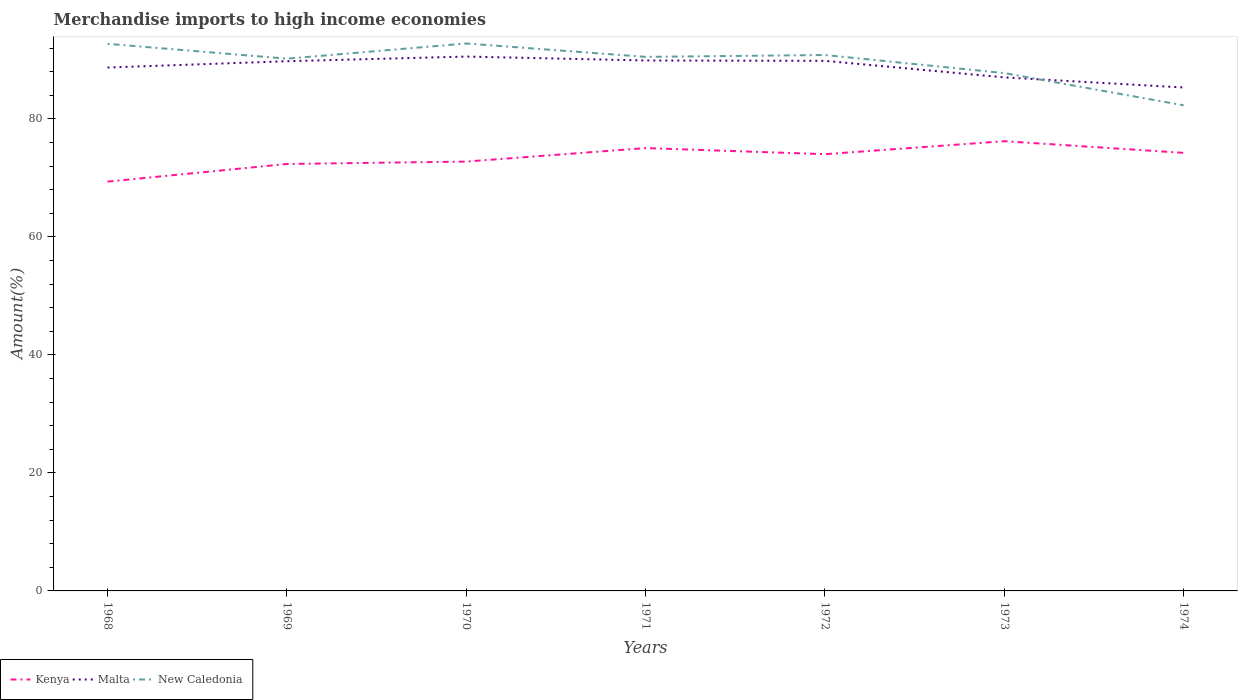Across all years, what is the maximum percentage of amount earned from merchandise imports in New Caledonia?
Offer a terse response. 82.3. In which year was the percentage of amount earned from merchandise imports in Malta maximum?
Ensure brevity in your answer.  1974. What is the total percentage of amount earned from merchandise imports in Kenya in the graph?
Give a very brief answer. -0.4. What is the difference between the highest and the second highest percentage of amount earned from merchandise imports in New Caledonia?
Make the answer very short. 10.48. Does the graph contain any zero values?
Ensure brevity in your answer.  No. Does the graph contain grids?
Provide a short and direct response. No. Where does the legend appear in the graph?
Provide a short and direct response. Bottom left. How many legend labels are there?
Keep it short and to the point. 3. How are the legend labels stacked?
Provide a short and direct response. Horizontal. What is the title of the graph?
Your answer should be compact. Merchandise imports to high income economies. What is the label or title of the X-axis?
Offer a terse response. Years. What is the label or title of the Y-axis?
Your answer should be compact. Amount(%). What is the Amount(%) of Kenya in 1968?
Keep it short and to the point. 69.36. What is the Amount(%) of Malta in 1968?
Your response must be concise. 88.7. What is the Amount(%) of New Caledonia in 1968?
Your response must be concise. 92.72. What is the Amount(%) of Kenya in 1969?
Your answer should be compact. 72.36. What is the Amount(%) in Malta in 1969?
Ensure brevity in your answer.  89.77. What is the Amount(%) of New Caledonia in 1969?
Provide a short and direct response. 90.2. What is the Amount(%) in Kenya in 1970?
Provide a short and direct response. 72.76. What is the Amount(%) of Malta in 1970?
Your response must be concise. 90.56. What is the Amount(%) of New Caledonia in 1970?
Keep it short and to the point. 92.78. What is the Amount(%) in Kenya in 1971?
Make the answer very short. 75.05. What is the Amount(%) of Malta in 1971?
Offer a terse response. 89.9. What is the Amount(%) in New Caledonia in 1971?
Offer a terse response. 90.51. What is the Amount(%) in Kenya in 1972?
Provide a short and direct response. 74.02. What is the Amount(%) in Malta in 1972?
Your answer should be compact. 89.83. What is the Amount(%) in New Caledonia in 1972?
Provide a short and direct response. 90.83. What is the Amount(%) in Kenya in 1973?
Your answer should be compact. 76.22. What is the Amount(%) of Malta in 1973?
Make the answer very short. 87.03. What is the Amount(%) in New Caledonia in 1973?
Your answer should be compact. 87.75. What is the Amount(%) of Kenya in 1974?
Offer a terse response. 74.24. What is the Amount(%) in Malta in 1974?
Give a very brief answer. 85.32. What is the Amount(%) in New Caledonia in 1974?
Provide a succinct answer. 82.3. Across all years, what is the maximum Amount(%) of Kenya?
Your answer should be very brief. 76.22. Across all years, what is the maximum Amount(%) of Malta?
Provide a succinct answer. 90.56. Across all years, what is the maximum Amount(%) of New Caledonia?
Make the answer very short. 92.78. Across all years, what is the minimum Amount(%) of Kenya?
Ensure brevity in your answer.  69.36. Across all years, what is the minimum Amount(%) in Malta?
Give a very brief answer. 85.32. Across all years, what is the minimum Amount(%) of New Caledonia?
Your response must be concise. 82.3. What is the total Amount(%) of Kenya in the graph?
Make the answer very short. 514.01. What is the total Amount(%) of Malta in the graph?
Your response must be concise. 621.12. What is the total Amount(%) in New Caledonia in the graph?
Provide a succinct answer. 627.08. What is the difference between the Amount(%) of Kenya in 1968 and that in 1969?
Keep it short and to the point. -2.99. What is the difference between the Amount(%) of Malta in 1968 and that in 1969?
Your answer should be compact. -1.07. What is the difference between the Amount(%) of New Caledonia in 1968 and that in 1969?
Provide a succinct answer. 2.52. What is the difference between the Amount(%) of Kenya in 1968 and that in 1970?
Provide a succinct answer. -3.4. What is the difference between the Amount(%) in Malta in 1968 and that in 1970?
Provide a short and direct response. -1.86. What is the difference between the Amount(%) in New Caledonia in 1968 and that in 1970?
Provide a succinct answer. -0.06. What is the difference between the Amount(%) of Kenya in 1968 and that in 1971?
Make the answer very short. -5.69. What is the difference between the Amount(%) in Malta in 1968 and that in 1971?
Your response must be concise. -1.19. What is the difference between the Amount(%) of New Caledonia in 1968 and that in 1971?
Ensure brevity in your answer.  2.21. What is the difference between the Amount(%) in Kenya in 1968 and that in 1972?
Make the answer very short. -4.65. What is the difference between the Amount(%) of Malta in 1968 and that in 1972?
Keep it short and to the point. -1.13. What is the difference between the Amount(%) in New Caledonia in 1968 and that in 1972?
Your response must be concise. 1.9. What is the difference between the Amount(%) of Kenya in 1968 and that in 1973?
Offer a very short reply. -6.85. What is the difference between the Amount(%) in Malta in 1968 and that in 1973?
Keep it short and to the point. 1.67. What is the difference between the Amount(%) in New Caledonia in 1968 and that in 1973?
Give a very brief answer. 4.97. What is the difference between the Amount(%) of Kenya in 1968 and that in 1974?
Provide a short and direct response. -4.87. What is the difference between the Amount(%) in Malta in 1968 and that in 1974?
Provide a succinct answer. 3.38. What is the difference between the Amount(%) in New Caledonia in 1968 and that in 1974?
Your answer should be very brief. 10.43. What is the difference between the Amount(%) in Kenya in 1969 and that in 1970?
Provide a succinct answer. -0.4. What is the difference between the Amount(%) in Malta in 1969 and that in 1970?
Keep it short and to the point. -0.79. What is the difference between the Amount(%) in New Caledonia in 1969 and that in 1970?
Provide a succinct answer. -2.58. What is the difference between the Amount(%) in Kenya in 1969 and that in 1971?
Give a very brief answer. -2.69. What is the difference between the Amount(%) in Malta in 1969 and that in 1971?
Give a very brief answer. -0.13. What is the difference between the Amount(%) in New Caledonia in 1969 and that in 1971?
Make the answer very short. -0.31. What is the difference between the Amount(%) in Kenya in 1969 and that in 1972?
Provide a short and direct response. -1.66. What is the difference between the Amount(%) in Malta in 1969 and that in 1972?
Give a very brief answer. -0.06. What is the difference between the Amount(%) in New Caledonia in 1969 and that in 1972?
Offer a terse response. -0.62. What is the difference between the Amount(%) of Kenya in 1969 and that in 1973?
Make the answer very short. -3.86. What is the difference between the Amount(%) of Malta in 1969 and that in 1973?
Provide a succinct answer. 2.74. What is the difference between the Amount(%) of New Caledonia in 1969 and that in 1973?
Provide a short and direct response. 2.45. What is the difference between the Amount(%) of Kenya in 1969 and that in 1974?
Ensure brevity in your answer.  -1.88. What is the difference between the Amount(%) in Malta in 1969 and that in 1974?
Your answer should be very brief. 4.45. What is the difference between the Amount(%) of New Caledonia in 1969 and that in 1974?
Provide a succinct answer. 7.91. What is the difference between the Amount(%) in Kenya in 1970 and that in 1971?
Give a very brief answer. -2.29. What is the difference between the Amount(%) of Malta in 1970 and that in 1971?
Your response must be concise. 0.66. What is the difference between the Amount(%) of New Caledonia in 1970 and that in 1971?
Make the answer very short. 2.27. What is the difference between the Amount(%) in Kenya in 1970 and that in 1972?
Provide a short and direct response. -1.26. What is the difference between the Amount(%) of Malta in 1970 and that in 1972?
Give a very brief answer. 0.73. What is the difference between the Amount(%) of New Caledonia in 1970 and that in 1972?
Your answer should be very brief. 1.95. What is the difference between the Amount(%) of Kenya in 1970 and that in 1973?
Keep it short and to the point. -3.45. What is the difference between the Amount(%) in Malta in 1970 and that in 1973?
Give a very brief answer. 3.53. What is the difference between the Amount(%) in New Caledonia in 1970 and that in 1973?
Your response must be concise. 5.02. What is the difference between the Amount(%) of Kenya in 1970 and that in 1974?
Give a very brief answer. -1.48. What is the difference between the Amount(%) in Malta in 1970 and that in 1974?
Your answer should be compact. 5.24. What is the difference between the Amount(%) of New Caledonia in 1970 and that in 1974?
Your response must be concise. 10.48. What is the difference between the Amount(%) in Kenya in 1971 and that in 1972?
Provide a succinct answer. 1.03. What is the difference between the Amount(%) in Malta in 1971 and that in 1972?
Offer a very short reply. 0.06. What is the difference between the Amount(%) of New Caledonia in 1971 and that in 1972?
Keep it short and to the point. -0.32. What is the difference between the Amount(%) in Kenya in 1971 and that in 1973?
Ensure brevity in your answer.  -1.16. What is the difference between the Amount(%) of Malta in 1971 and that in 1973?
Give a very brief answer. 2.87. What is the difference between the Amount(%) in New Caledonia in 1971 and that in 1973?
Offer a terse response. 2.75. What is the difference between the Amount(%) of Kenya in 1971 and that in 1974?
Ensure brevity in your answer.  0.81. What is the difference between the Amount(%) in Malta in 1971 and that in 1974?
Keep it short and to the point. 4.58. What is the difference between the Amount(%) of New Caledonia in 1971 and that in 1974?
Make the answer very short. 8.21. What is the difference between the Amount(%) of Kenya in 1972 and that in 1973?
Offer a terse response. -2.2. What is the difference between the Amount(%) of Malta in 1972 and that in 1973?
Offer a terse response. 2.8. What is the difference between the Amount(%) of New Caledonia in 1972 and that in 1973?
Your response must be concise. 3.07. What is the difference between the Amount(%) in Kenya in 1972 and that in 1974?
Offer a terse response. -0.22. What is the difference between the Amount(%) in Malta in 1972 and that in 1974?
Your response must be concise. 4.52. What is the difference between the Amount(%) of New Caledonia in 1972 and that in 1974?
Your response must be concise. 8.53. What is the difference between the Amount(%) of Kenya in 1973 and that in 1974?
Your answer should be very brief. 1.98. What is the difference between the Amount(%) in Malta in 1973 and that in 1974?
Ensure brevity in your answer.  1.71. What is the difference between the Amount(%) in New Caledonia in 1973 and that in 1974?
Provide a short and direct response. 5.46. What is the difference between the Amount(%) in Kenya in 1968 and the Amount(%) in Malta in 1969?
Your response must be concise. -20.41. What is the difference between the Amount(%) in Kenya in 1968 and the Amount(%) in New Caledonia in 1969?
Provide a succinct answer. -20.84. What is the difference between the Amount(%) of Malta in 1968 and the Amount(%) of New Caledonia in 1969?
Offer a very short reply. -1.5. What is the difference between the Amount(%) of Kenya in 1968 and the Amount(%) of Malta in 1970?
Provide a short and direct response. -21.2. What is the difference between the Amount(%) in Kenya in 1968 and the Amount(%) in New Caledonia in 1970?
Provide a short and direct response. -23.41. What is the difference between the Amount(%) of Malta in 1968 and the Amount(%) of New Caledonia in 1970?
Offer a very short reply. -4.07. What is the difference between the Amount(%) of Kenya in 1968 and the Amount(%) of Malta in 1971?
Make the answer very short. -20.53. What is the difference between the Amount(%) of Kenya in 1968 and the Amount(%) of New Caledonia in 1971?
Your response must be concise. -21.14. What is the difference between the Amount(%) of Malta in 1968 and the Amount(%) of New Caledonia in 1971?
Make the answer very short. -1.81. What is the difference between the Amount(%) of Kenya in 1968 and the Amount(%) of Malta in 1972?
Provide a short and direct response. -20.47. What is the difference between the Amount(%) in Kenya in 1968 and the Amount(%) in New Caledonia in 1972?
Your response must be concise. -21.46. What is the difference between the Amount(%) in Malta in 1968 and the Amount(%) in New Caledonia in 1972?
Ensure brevity in your answer.  -2.12. What is the difference between the Amount(%) of Kenya in 1968 and the Amount(%) of Malta in 1973?
Your answer should be compact. -17.67. What is the difference between the Amount(%) of Kenya in 1968 and the Amount(%) of New Caledonia in 1973?
Offer a very short reply. -18.39. What is the difference between the Amount(%) in Malta in 1968 and the Amount(%) in New Caledonia in 1973?
Provide a short and direct response. 0.95. What is the difference between the Amount(%) of Kenya in 1968 and the Amount(%) of Malta in 1974?
Ensure brevity in your answer.  -15.95. What is the difference between the Amount(%) of Kenya in 1968 and the Amount(%) of New Caledonia in 1974?
Ensure brevity in your answer.  -12.93. What is the difference between the Amount(%) of Malta in 1968 and the Amount(%) of New Caledonia in 1974?
Ensure brevity in your answer.  6.41. What is the difference between the Amount(%) in Kenya in 1969 and the Amount(%) in Malta in 1970?
Your answer should be very brief. -18.2. What is the difference between the Amount(%) of Kenya in 1969 and the Amount(%) of New Caledonia in 1970?
Provide a short and direct response. -20.42. What is the difference between the Amount(%) of Malta in 1969 and the Amount(%) of New Caledonia in 1970?
Your answer should be compact. -3.01. What is the difference between the Amount(%) in Kenya in 1969 and the Amount(%) in Malta in 1971?
Your response must be concise. -17.54. What is the difference between the Amount(%) in Kenya in 1969 and the Amount(%) in New Caledonia in 1971?
Your answer should be compact. -18.15. What is the difference between the Amount(%) in Malta in 1969 and the Amount(%) in New Caledonia in 1971?
Give a very brief answer. -0.74. What is the difference between the Amount(%) in Kenya in 1969 and the Amount(%) in Malta in 1972?
Your response must be concise. -17.48. What is the difference between the Amount(%) of Kenya in 1969 and the Amount(%) of New Caledonia in 1972?
Ensure brevity in your answer.  -18.47. What is the difference between the Amount(%) in Malta in 1969 and the Amount(%) in New Caledonia in 1972?
Your response must be concise. -1.05. What is the difference between the Amount(%) of Kenya in 1969 and the Amount(%) of Malta in 1973?
Offer a very short reply. -14.67. What is the difference between the Amount(%) in Kenya in 1969 and the Amount(%) in New Caledonia in 1973?
Your answer should be very brief. -15.4. What is the difference between the Amount(%) of Malta in 1969 and the Amount(%) of New Caledonia in 1973?
Give a very brief answer. 2.02. What is the difference between the Amount(%) of Kenya in 1969 and the Amount(%) of Malta in 1974?
Provide a short and direct response. -12.96. What is the difference between the Amount(%) of Kenya in 1969 and the Amount(%) of New Caledonia in 1974?
Ensure brevity in your answer.  -9.94. What is the difference between the Amount(%) in Malta in 1969 and the Amount(%) in New Caledonia in 1974?
Your answer should be compact. 7.48. What is the difference between the Amount(%) in Kenya in 1970 and the Amount(%) in Malta in 1971?
Keep it short and to the point. -17.14. What is the difference between the Amount(%) in Kenya in 1970 and the Amount(%) in New Caledonia in 1971?
Your answer should be very brief. -17.75. What is the difference between the Amount(%) in Malta in 1970 and the Amount(%) in New Caledonia in 1971?
Offer a very short reply. 0.05. What is the difference between the Amount(%) of Kenya in 1970 and the Amount(%) of Malta in 1972?
Your answer should be very brief. -17.07. What is the difference between the Amount(%) of Kenya in 1970 and the Amount(%) of New Caledonia in 1972?
Ensure brevity in your answer.  -18.06. What is the difference between the Amount(%) of Malta in 1970 and the Amount(%) of New Caledonia in 1972?
Your answer should be very brief. -0.26. What is the difference between the Amount(%) in Kenya in 1970 and the Amount(%) in Malta in 1973?
Provide a succinct answer. -14.27. What is the difference between the Amount(%) in Kenya in 1970 and the Amount(%) in New Caledonia in 1973?
Your answer should be compact. -14.99. What is the difference between the Amount(%) of Malta in 1970 and the Amount(%) of New Caledonia in 1973?
Make the answer very short. 2.81. What is the difference between the Amount(%) of Kenya in 1970 and the Amount(%) of Malta in 1974?
Provide a short and direct response. -12.56. What is the difference between the Amount(%) in Kenya in 1970 and the Amount(%) in New Caledonia in 1974?
Your answer should be very brief. -9.53. What is the difference between the Amount(%) of Malta in 1970 and the Amount(%) of New Caledonia in 1974?
Make the answer very short. 8.27. What is the difference between the Amount(%) in Kenya in 1971 and the Amount(%) in Malta in 1972?
Keep it short and to the point. -14.78. What is the difference between the Amount(%) of Kenya in 1971 and the Amount(%) of New Caledonia in 1972?
Offer a very short reply. -15.77. What is the difference between the Amount(%) in Malta in 1971 and the Amount(%) in New Caledonia in 1972?
Offer a very short reply. -0.93. What is the difference between the Amount(%) of Kenya in 1971 and the Amount(%) of Malta in 1973?
Make the answer very short. -11.98. What is the difference between the Amount(%) in Kenya in 1971 and the Amount(%) in New Caledonia in 1973?
Your answer should be compact. -12.7. What is the difference between the Amount(%) of Malta in 1971 and the Amount(%) of New Caledonia in 1973?
Your answer should be compact. 2.14. What is the difference between the Amount(%) in Kenya in 1971 and the Amount(%) in Malta in 1974?
Your answer should be very brief. -10.27. What is the difference between the Amount(%) of Kenya in 1971 and the Amount(%) of New Caledonia in 1974?
Offer a very short reply. -7.24. What is the difference between the Amount(%) in Malta in 1971 and the Amount(%) in New Caledonia in 1974?
Offer a terse response. 7.6. What is the difference between the Amount(%) of Kenya in 1972 and the Amount(%) of Malta in 1973?
Your response must be concise. -13.01. What is the difference between the Amount(%) in Kenya in 1972 and the Amount(%) in New Caledonia in 1973?
Offer a very short reply. -13.74. What is the difference between the Amount(%) of Malta in 1972 and the Amount(%) of New Caledonia in 1973?
Your answer should be very brief. 2.08. What is the difference between the Amount(%) of Kenya in 1972 and the Amount(%) of Malta in 1974?
Offer a very short reply. -11.3. What is the difference between the Amount(%) of Kenya in 1972 and the Amount(%) of New Caledonia in 1974?
Your answer should be compact. -8.28. What is the difference between the Amount(%) of Malta in 1972 and the Amount(%) of New Caledonia in 1974?
Offer a very short reply. 7.54. What is the difference between the Amount(%) of Kenya in 1973 and the Amount(%) of Malta in 1974?
Offer a very short reply. -9.1. What is the difference between the Amount(%) of Kenya in 1973 and the Amount(%) of New Caledonia in 1974?
Provide a short and direct response. -6.08. What is the difference between the Amount(%) of Malta in 1973 and the Amount(%) of New Caledonia in 1974?
Give a very brief answer. 4.74. What is the average Amount(%) in Kenya per year?
Ensure brevity in your answer.  73.43. What is the average Amount(%) of Malta per year?
Your answer should be very brief. 88.73. What is the average Amount(%) in New Caledonia per year?
Ensure brevity in your answer.  89.58. In the year 1968, what is the difference between the Amount(%) of Kenya and Amount(%) of Malta?
Provide a succinct answer. -19.34. In the year 1968, what is the difference between the Amount(%) of Kenya and Amount(%) of New Caledonia?
Your response must be concise. -23.36. In the year 1968, what is the difference between the Amount(%) of Malta and Amount(%) of New Caledonia?
Make the answer very short. -4.02. In the year 1969, what is the difference between the Amount(%) in Kenya and Amount(%) in Malta?
Your answer should be compact. -17.41. In the year 1969, what is the difference between the Amount(%) of Kenya and Amount(%) of New Caledonia?
Offer a terse response. -17.84. In the year 1969, what is the difference between the Amount(%) in Malta and Amount(%) in New Caledonia?
Offer a very short reply. -0.43. In the year 1970, what is the difference between the Amount(%) in Kenya and Amount(%) in Malta?
Your answer should be compact. -17.8. In the year 1970, what is the difference between the Amount(%) of Kenya and Amount(%) of New Caledonia?
Offer a terse response. -20.02. In the year 1970, what is the difference between the Amount(%) of Malta and Amount(%) of New Caledonia?
Offer a terse response. -2.22. In the year 1971, what is the difference between the Amount(%) of Kenya and Amount(%) of Malta?
Keep it short and to the point. -14.85. In the year 1971, what is the difference between the Amount(%) of Kenya and Amount(%) of New Caledonia?
Make the answer very short. -15.46. In the year 1971, what is the difference between the Amount(%) of Malta and Amount(%) of New Caledonia?
Provide a succinct answer. -0.61. In the year 1972, what is the difference between the Amount(%) in Kenya and Amount(%) in Malta?
Your response must be concise. -15.82. In the year 1972, what is the difference between the Amount(%) of Kenya and Amount(%) of New Caledonia?
Your answer should be very brief. -16.81. In the year 1972, what is the difference between the Amount(%) in Malta and Amount(%) in New Caledonia?
Offer a terse response. -0.99. In the year 1973, what is the difference between the Amount(%) of Kenya and Amount(%) of Malta?
Your answer should be compact. -10.82. In the year 1973, what is the difference between the Amount(%) in Kenya and Amount(%) in New Caledonia?
Offer a very short reply. -11.54. In the year 1973, what is the difference between the Amount(%) of Malta and Amount(%) of New Caledonia?
Your answer should be very brief. -0.72. In the year 1974, what is the difference between the Amount(%) in Kenya and Amount(%) in Malta?
Your answer should be very brief. -11.08. In the year 1974, what is the difference between the Amount(%) of Kenya and Amount(%) of New Caledonia?
Offer a very short reply. -8.06. In the year 1974, what is the difference between the Amount(%) of Malta and Amount(%) of New Caledonia?
Provide a succinct answer. 3.02. What is the ratio of the Amount(%) in Kenya in 1968 to that in 1969?
Offer a terse response. 0.96. What is the ratio of the Amount(%) in New Caledonia in 1968 to that in 1969?
Your response must be concise. 1.03. What is the ratio of the Amount(%) of Kenya in 1968 to that in 1970?
Make the answer very short. 0.95. What is the ratio of the Amount(%) of Malta in 1968 to that in 1970?
Give a very brief answer. 0.98. What is the ratio of the Amount(%) in Kenya in 1968 to that in 1971?
Keep it short and to the point. 0.92. What is the ratio of the Amount(%) of Malta in 1968 to that in 1971?
Your response must be concise. 0.99. What is the ratio of the Amount(%) of New Caledonia in 1968 to that in 1971?
Offer a terse response. 1.02. What is the ratio of the Amount(%) in Kenya in 1968 to that in 1972?
Your answer should be very brief. 0.94. What is the ratio of the Amount(%) in Malta in 1968 to that in 1972?
Give a very brief answer. 0.99. What is the ratio of the Amount(%) of New Caledonia in 1968 to that in 1972?
Make the answer very short. 1.02. What is the ratio of the Amount(%) of Kenya in 1968 to that in 1973?
Keep it short and to the point. 0.91. What is the ratio of the Amount(%) in Malta in 1968 to that in 1973?
Provide a succinct answer. 1.02. What is the ratio of the Amount(%) of New Caledonia in 1968 to that in 1973?
Provide a succinct answer. 1.06. What is the ratio of the Amount(%) in Kenya in 1968 to that in 1974?
Give a very brief answer. 0.93. What is the ratio of the Amount(%) of Malta in 1968 to that in 1974?
Ensure brevity in your answer.  1.04. What is the ratio of the Amount(%) of New Caledonia in 1968 to that in 1974?
Your answer should be very brief. 1.13. What is the ratio of the Amount(%) in Kenya in 1969 to that in 1970?
Your answer should be very brief. 0.99. What is the ratio of the Amount(%) in Malta in 1969 to that in 1970?
Your response must be concise. 0.99. What is the ratio of the Amount(%) of New Caledonia in 1969 to that in 1970?
Your answer should be compact. 0.97. What is the ratio of the Amount(%) in Kenya in 1969 to that in 1971?
Your response must be concise. 0.96. What is the ratio of the Amount(%) in Malta in 1969 to that in 1971?
Give a very brief answer. 1. What is the ratio of the Amount(%) of New Caledonia in 1969 to that in 1971?
Provide a short and direct response. 1. What is the ratio of the Amount(%) of Kenya in 1969 to that in 1972?
Offer a terse response. 0.98. What is the ratio of the Amount(%) of Malta in 1969 to that in 1972?
Give a very brief answer. 1. What is the ratio of the Amount(%) in New Caledonia in 1969 to that in 1972?
Your answer should be compact. 0.99. What is the ratio of the Amount(%) in Kenya in 1969 to that in 1973?
Provide a short and direct response. 0.95. What is the ratio of the Amount(%) in Malta in 1969 to that in 1973?
Provide a short and direct response. 1.03. What is the ratio of the Amount(%) of New Caledonia in 1969 to that in 1973?
Your response must be concise. 1.03. What is the ratio of the Amount(%) in Kenya in 1969 to that in 1974?
Keep it short and to the point. 0.97. What is the ratio of the Amount(%) of Malta in 1969 to that in 1974?
Give a very brief answer. 1.05. What is the ratio of the Amount(%) of New Caledonia in 1969 to that in 1974?
Provide a succinct answer. 1.1. What is the ratio of the Amount(%) of Kenya in 1970 to that in 1971?
Provide a short and direct response. 0.97. What is the ratio of the Amount(%) of Malta in 1970 to that in 1971?
Your answer should be very brief. 1.01. What is the ratio of the Amount(%) in New Caledonia in 1970 to that in 1971?
Offer a terse response. 1.03. What is the ratio of the Amount(%) in Kenya in 1970 to that in 1972?
Your answer should be very brief. 0.98. What is the ratio of the Amount(%) of New Caledonia in 1970 to that in 1972?
Your answer should be compact. 1.02. What is the ratio of the Amount(%) in Kenya in 1970 to that in 1973?
Provide a short and direct response. 0.95. What is the ratio of the Amount(%) in Malta in 1970 to that in 1973?
Ensure brevity in your answer.  1.04. What is the ratio of the Amount(%) of New Caledonia in 1970 to that in 1973?
Keep it short and to the point. 1.06. What is the ratio of the Amount(%) in Kenya in 1970 to that in 1974?
Make the answer very short. 0.98. What is the ratio of the Amount(%) in Malta in 1970 to that in 1974?
Provide a short and direct response. 1.06. What is the ratio of the Amount(%) in New Caledonia in 1970 to that in 1974?
Provide a short and direct response. 1.13. What is the ratio of the Amount(%) in Kenya in 1971 to that in 1972?
Provide a short and direct response. 1.01. What is the ratio of the Amount(%) of New Caledonia in 1971 to that in 1972?
Offer a terse response. 1. What is the ratio of the Amount(%) of Kenya in 1971 to that in 1973?
Ensure brevity in your answer.  0.98. What is the ratio of the Amount(%) in Malta in 1971 to that in 1973?
Your answer should be very brief. 1.03. What is the ratio of the Amount(%) in New Caledonia in 1971 to that in 1973?
Provide a short and direct response. 1.03. What is the ratio of the Amount(%) of Kenya in 1971 to that in 1974?
Provide a succinct answer. 1.01. What is the ratio of the Amount(%) of Malta in 1971 to that in 1974?
Offer a very short reply. 1.05. What is the ratio of the Amount(%) in New Caledonia in 1971 to that in 1974?
Your answer should be compact. 1.1. What is the ratio of the Amount(%) of Kenya in 1972 to that in 1973?
Provide a succinct answer. 0.97. What is the ratio of the Amount(%) of Malta in 1972 to that in 1973?
Make the answer very short. 1.03. What is the ratio of the Amount(%) in New Caledonia in 1972 to that in 1973?
Ensure brevity in your answer.  1.03. What is the ratio of the Amount(%) of Malta in 1972 to that in 1974?
Keep it short and to the point. 1.05. What is the ratio of the Amount(%) in New Caledonia in 1972 to that in 1974?
Offer a very short reply. 1.1. What is the ratio of the Amount(%) of Kenya in 1973 to that in 1974?
Your answer should be compact. 1.03. What is the ratio of the Amount(%) of Malta in 1973 to that in 1974?
Offer a very short reply. 1.02. What is the ratio of the Amount(%) of New Caledonia in 1973 to that in 1974?
Give a very brief answer. 1.07. What is the difference between the highest and the second highest Amount(%) in Kenya?
Your answer should be very brief. 1.16. What is the difference between the highest and the second highest Amount(%) of Malta?
Your answer should be very brief. 0.66. What is the difference between the highest and the second highest Amount(%) of New Caledonia?
Your response must be concise. 0.06. What is the difference between the highest and the lowest Amount(%) of Kenya?
Ensure brevity in your answer.  6.85. What is the difference between the highest and the lowest Amount(%) in Malta?
Your answer should be very brief. 5.24. What is the difference between the highest and the lowest Amount(%) in New Caledonia?
Your answer should be very brief. 10.48. 